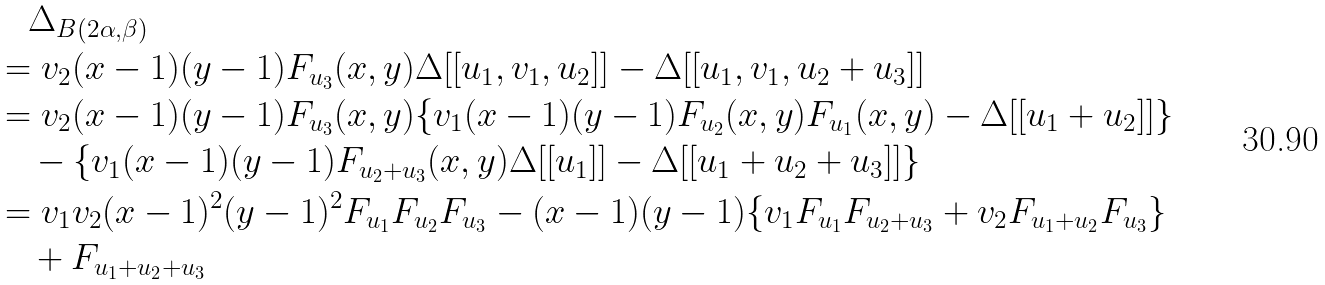<formula> <loc_0><loc_0><loc_500><loc_500>& \quad \Delta _ { B ( 2 \alpha , \beta ) } \\ & = v _ { 2 } ( x - 1 ) ( y - 1 ) F _ { u _ { 3 } } ( x , y ) \Delta [ [ u _ { 1 } , v _ { 1 } , u _ { 2 } ] ] - \Delta [ [ u _ { 1 } , v _ { 1 } , u _ { 2 } + u _ { 3 } ] ] \\ & = v _ { 2 } ( x - 1 ) ( y - 1 ) F _ { u _ { 3 } } ( x , y ) \{ v _ { 1 } ( x - 1 ) ( y - 1 ) F _ { u _ { 2 } } ( x , y ) F _ { u _ { 1 } } ( x , y ) - \Delta [ [ u _ { 1 } + u _ { 2 } ] ] \} \\ & \quad - \{ v _ { 1 } ( x - 1 ) ( y - 1 ) F _ { u _ { 2 } + u _ { 3 } } ( x , y ) \Delta [ [ u _ { 1 } ] ] - \Delta [ [ u _ { 1 } + u _ { 2 } + u _ { 3 } ] ] \} \\ & = v _ { 1 } v _ { 2 } ( x - 1 ) ^ { 2 } ( y - 1 ) ^ { 2 } F _ { u _ { 1 } } F _ { u _ { 2 } } F _ { u _ { 3 } } - ( x - 1 ) ( y - 1 ) \{ v _ { 1 } F _ { u _ { 1 } } F _ { u _ { 2 } + u _ { 3 } } + v _ { 2 } F _ { u _ { 1 } + u _ { 2 } } F _ { u _ { 3 } } \} \\ & \quad + F _ { u _ { 1 } + u _ { 2 } + u _ { 3 } }</formula> 